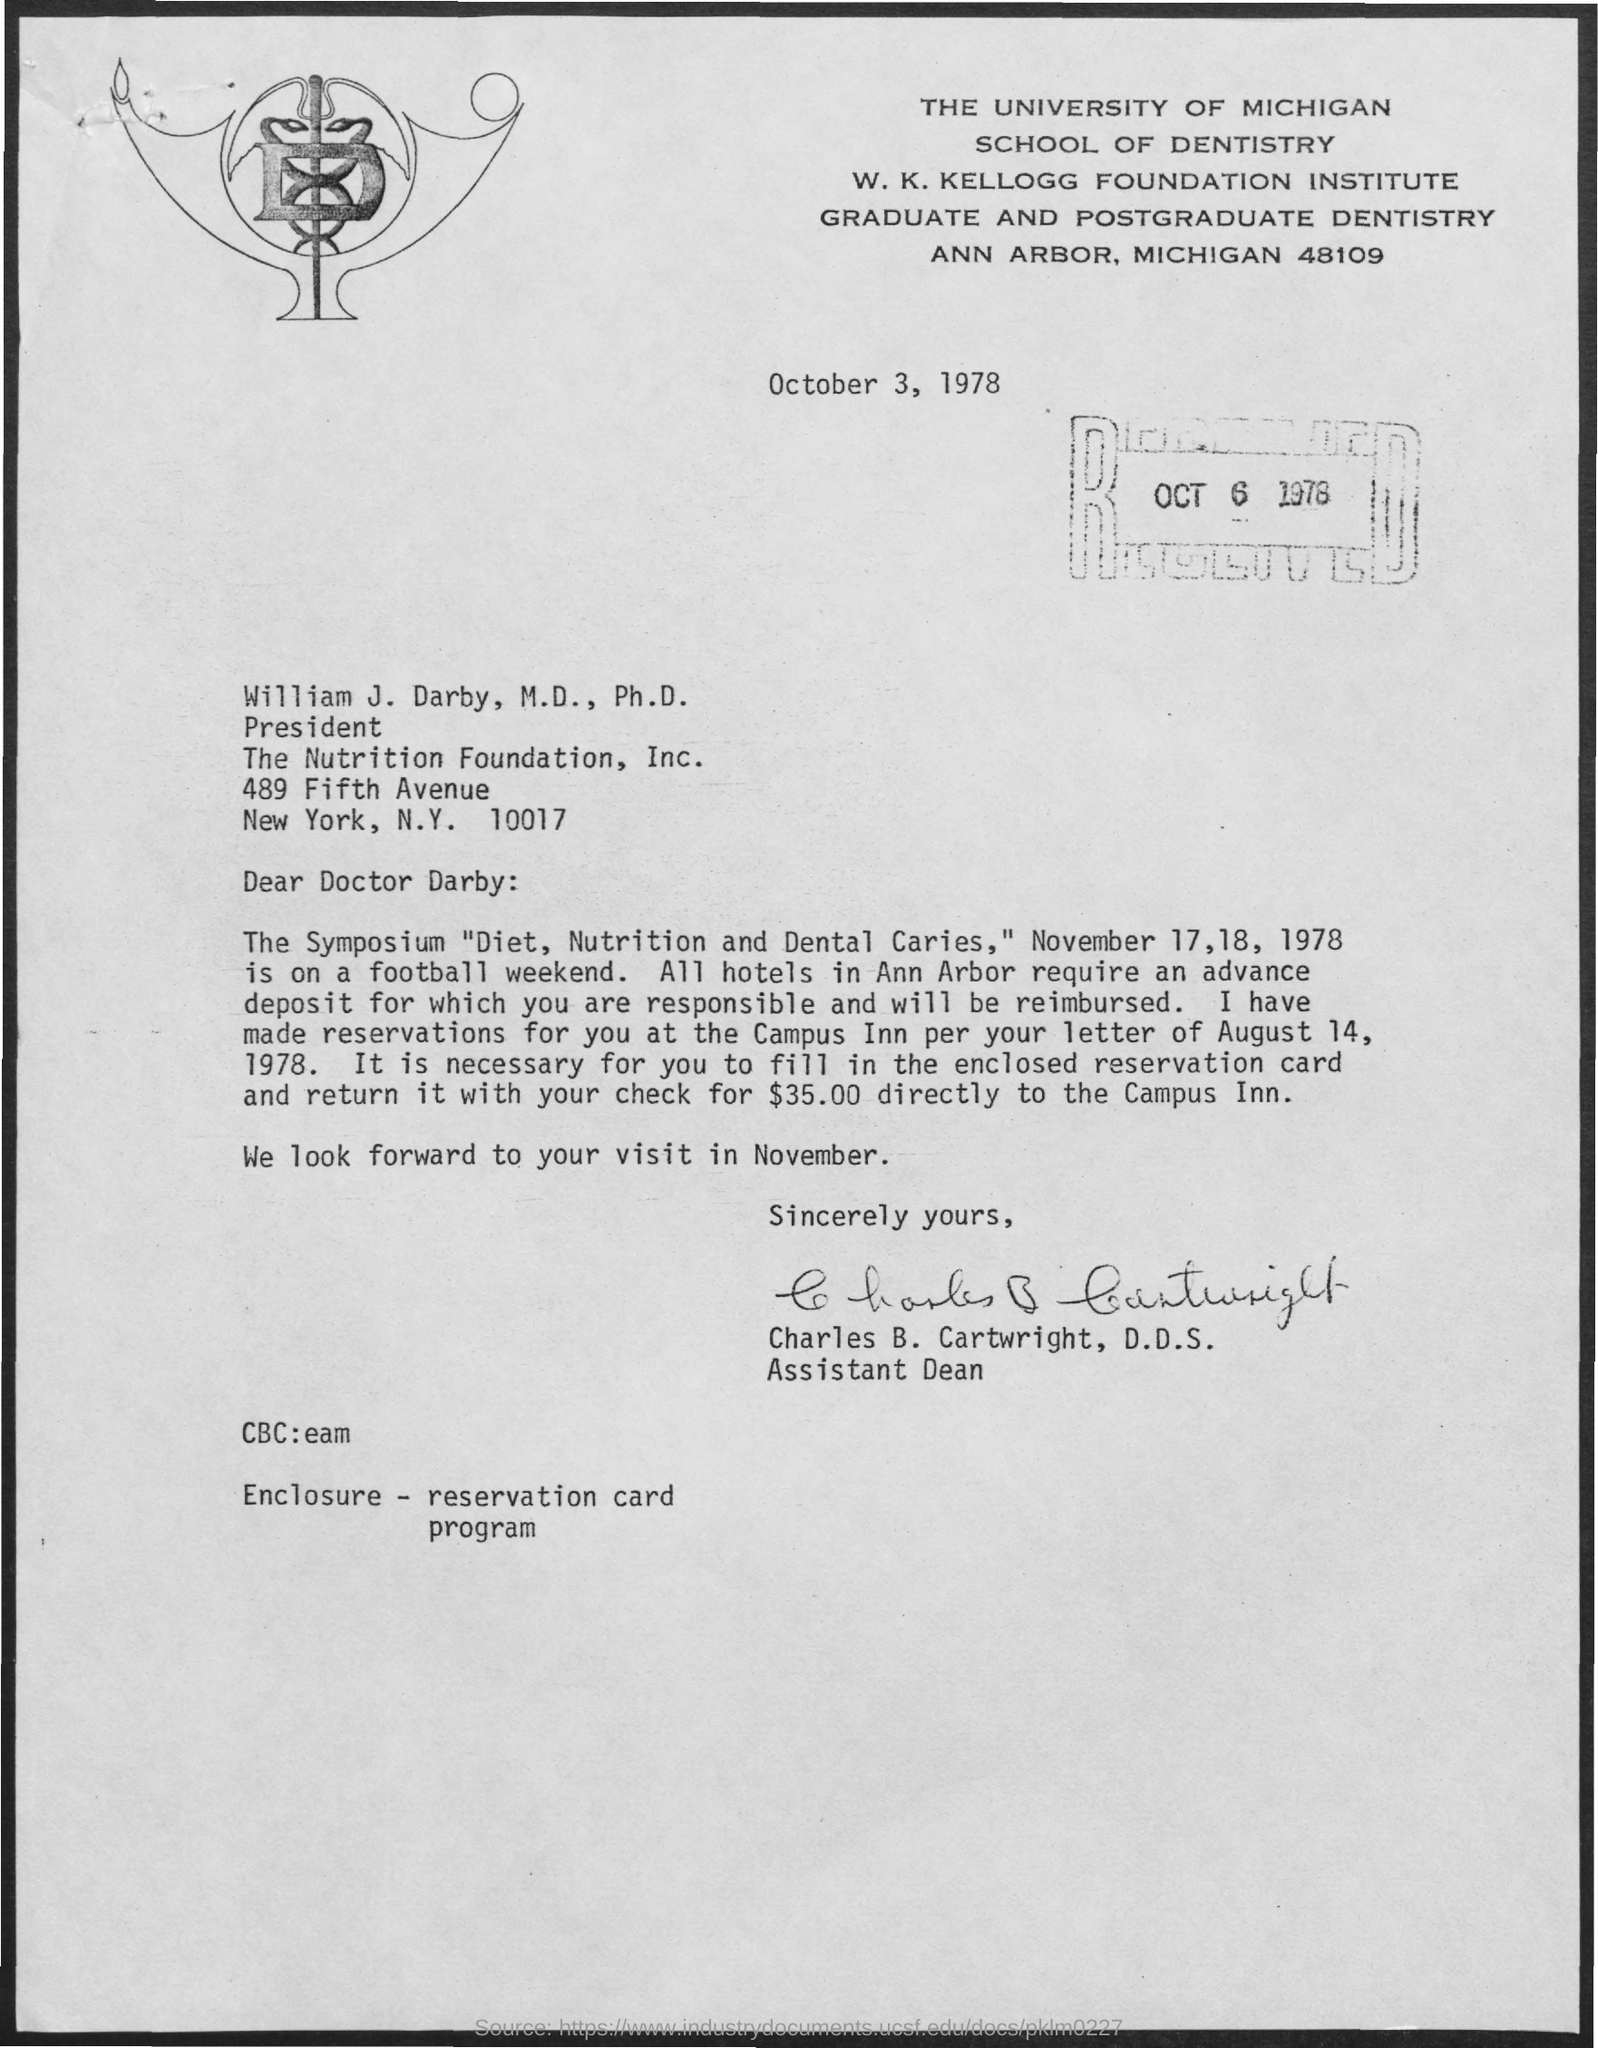Point out several critical features in this image. The received date of this letter is October 6, 1978. Charles B. Cartwright, D.D.S. holds the designation of Assistant Dean. 